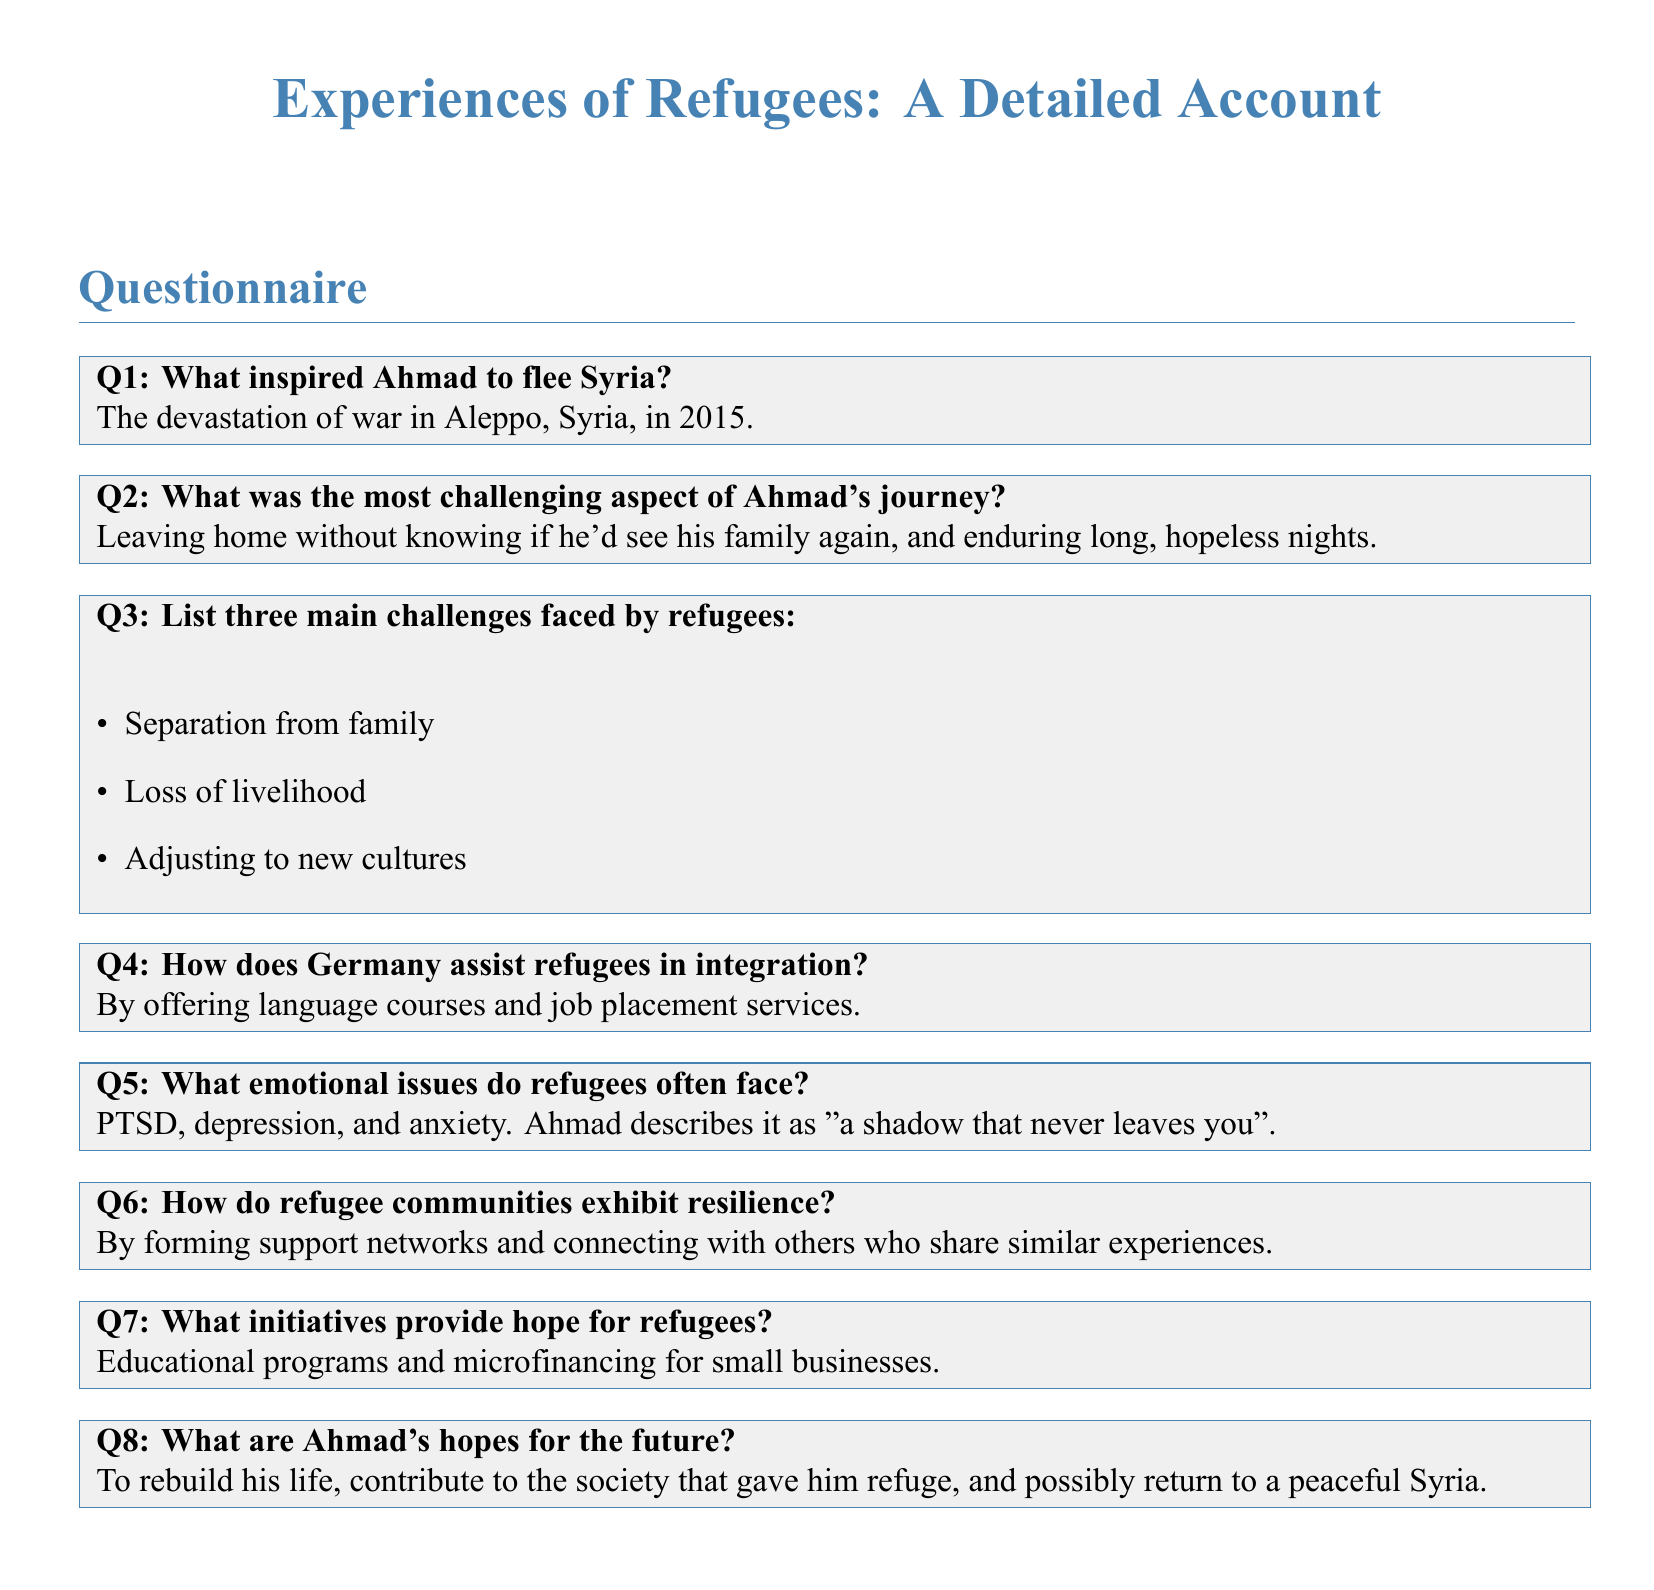What inspired Ahmad to flee Syria? The reason stated is the devastation of war in Aleppo, Syria, in 2015.
Answer: devastation of war in Aleppo, Syria, in 2015 What was the most challenging aspect of Ahmad's journey? Ahmad found it challenging to leave home without knowing if he'd see his family again and enduring long, hopeless nights.
Answer: Leaving home without knowing if he'd see his family again, and enduring long, hopeless nights What are three main challenges faced by refugees? The document lists separation from family, loss of livelihood, and adjusting to new cultures as major challenges.
Answer: Separation from family, loss of livelihood, adjusting to new cultures How does Germany assist refugees in integration? The information provided states that Germany offers language courses and job placement services to help refugees.
Answer: language courses and job placement services What emotional issues do refugees often face? Ahmad describes emotional issues faced by refugees including PTSD, depression, and anxiety.
Answer: PTSD, depression, and anxiety What initiatives provide hope for refugees? The document mentions educational programs and microfinancing for small businesses as initiatives that provide hope.
Answer: Educational programs and microfinancing for small businesses What are Ahmad's hopes for the future? Ahmad expresses hopes of rebuilding his life, contributing to society, and possibly returning to a peaceful Syria.
Answer: To rebuild his life, contribute to the society, and possibly return to a peaceful Syria 